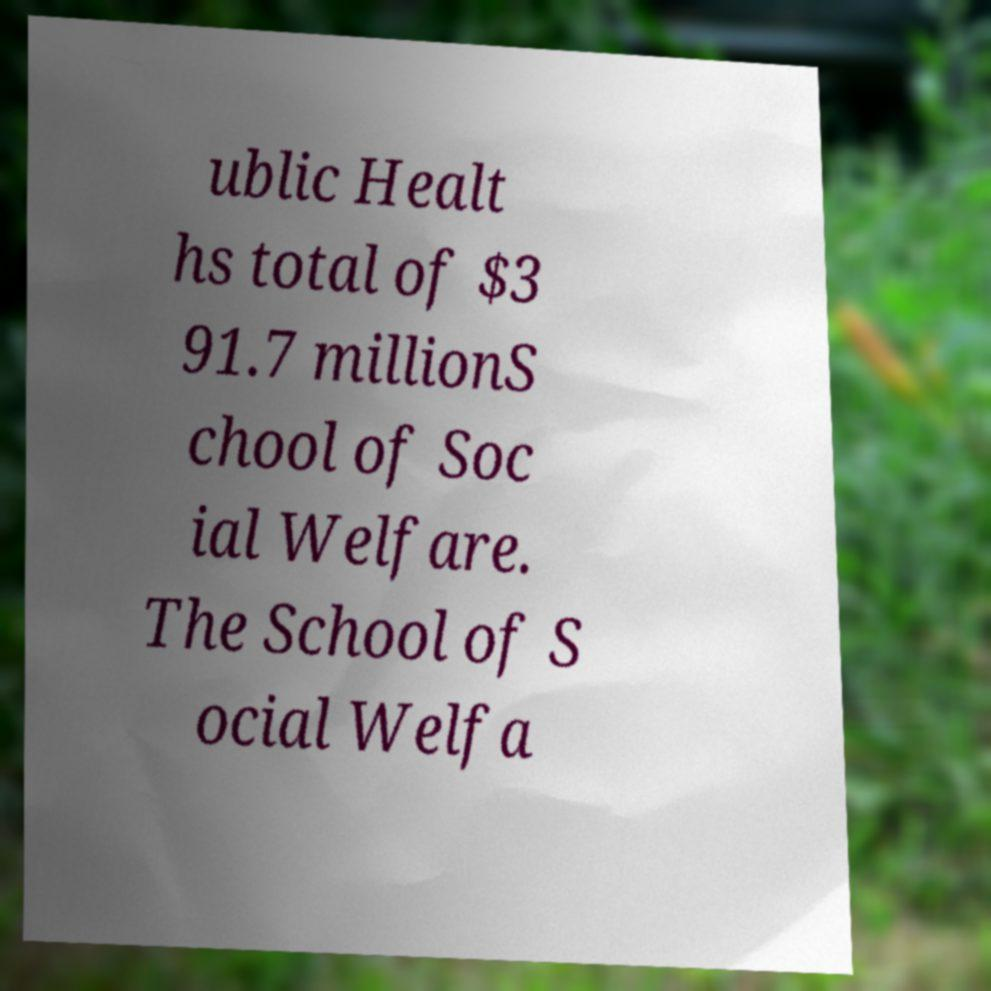I need the written content from this picture converted into text. Can you do that? ublic Healt hs total of $3 91.7 millionS chool of Soc ial Welfare. The School of S ocial Welfa 